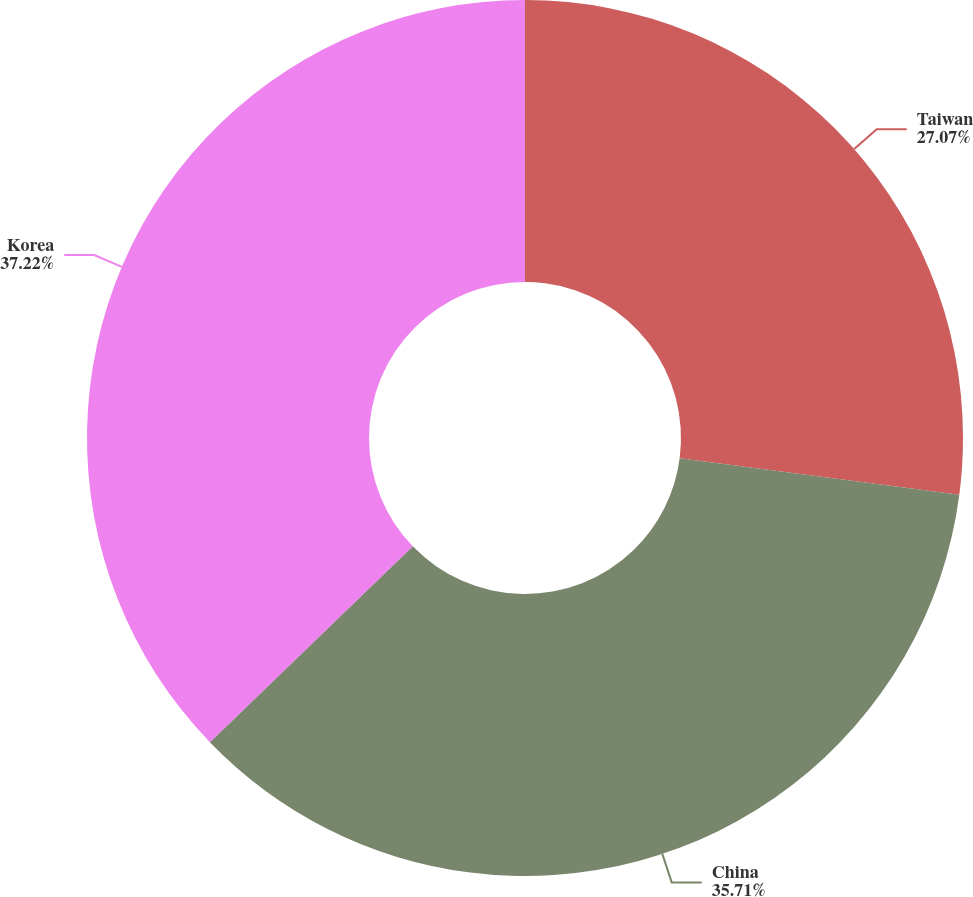Convert chart. <chart><loc_0><loc_0><loc_500><loc_500><pie_chart><fcel>Taiwan<fcel>China<fcel>Korea<nl><fcel>27.07%<fcel>35.71%<fcel>37.22%<nl></chart> 